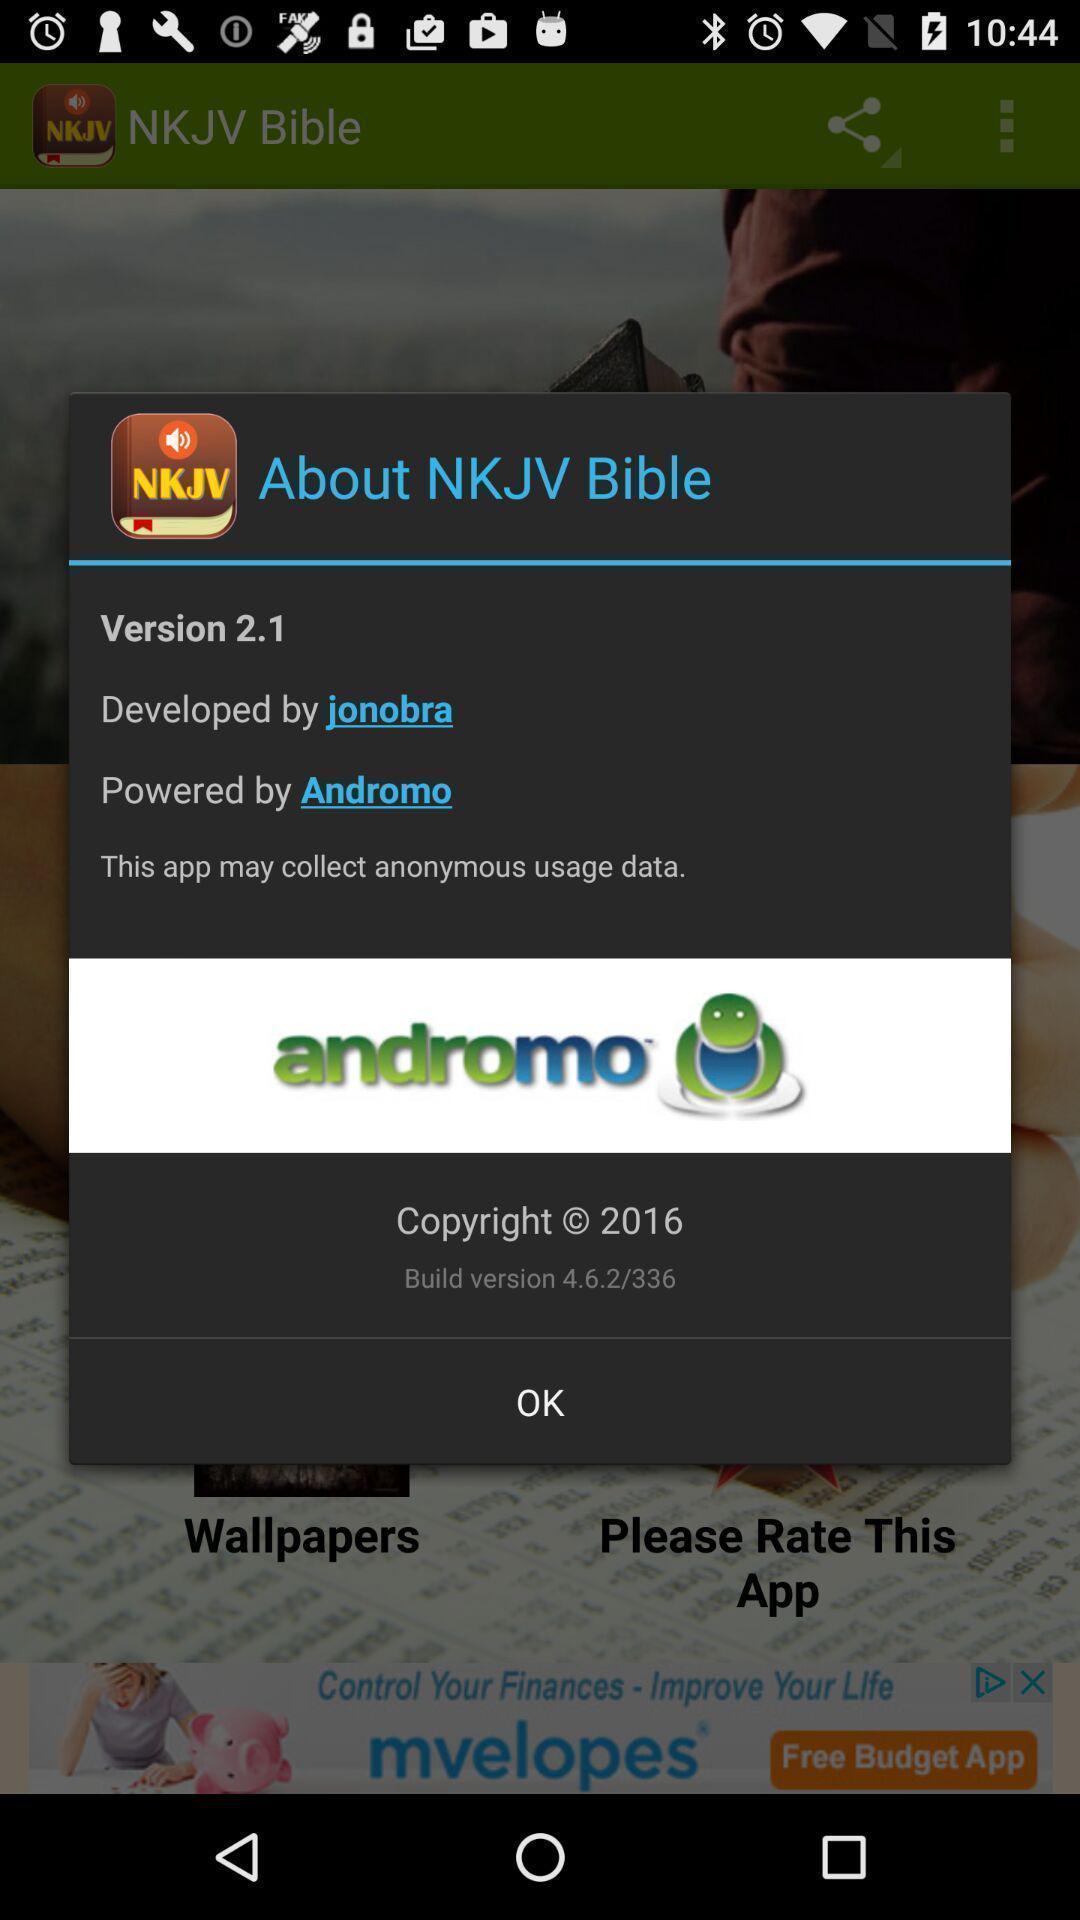Describe the key features of this screenshot. Pop up showing the app details. 